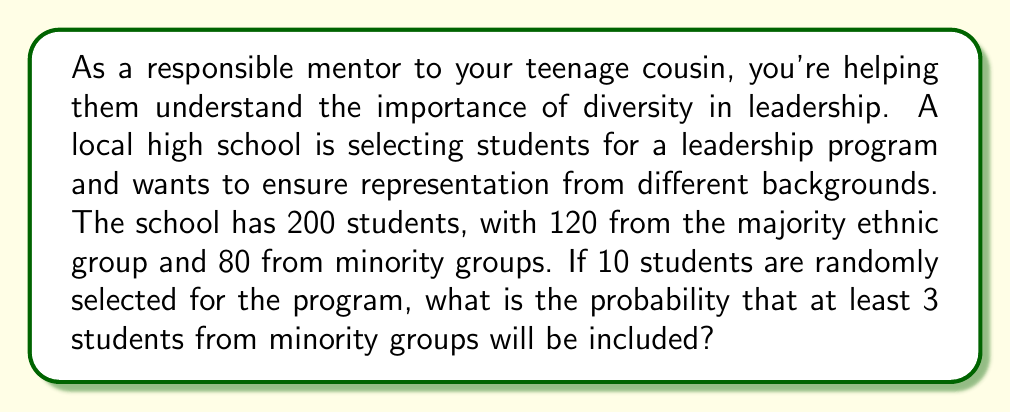What is the answer to this math problem? Let's approach this step-by-step:

1) This is a problem of hypergeometric distribution. We need to find the probability of selecting at least 3 students from minority groups out of 10 selected students.

2) Let's define our variables:
   $N$ = total number of students = 200
   $K$ = number of students from minority groups = 80
   $n$ = number of students selected for the program = 10
   $k$ = number of minority students we want in the selection (at least 3)

3) The probability of selecting exactly $x$ minority students is:

   $$P(X=x) = \frac{\binom{K}{x} \binom{N-K}{n-x}}{\binom{N}{n}}$$

4) We want the probability of selecting at least 3 minority students. This is equivalent to 1 minus the probability of selecting 0, 1, or 2 minority students:

   $$P(X \geq 3) = 1 - [P(X=0) + P(X=1) + P(X=2)]$$

5) Let's calculate each probability:

   $$P(X=0) = \frac{\binom{80}{0} \binom{120}{10}}{\binom{200}{10}} = \frac{1 \cdot 6,906,900}{22,451,004,309} \approx 0.0003076$$

   $$P(X=1) = \frac{\binom{80}{1} \binom{120}{9}}{\binom{200}{10}} = \frac{80 \cdot 1,677,106}{22,451,004,309} \approx 0.0059789$$

   $$P(X=2) = \frac{\binom{80}{2} \binom{120}{8}}{\binom{200}{10}} = \frac{3,160 \cdot 375,060}{22,451,004,309} \approx 0.0528173$$

6) Now, we can calculate the probability of at least 3 minority students:

   $$P(X \geq 3) = 1 - [0.0003076 + 0.0059789 + 0.0528173] = 1 - 0.0591038 = 0.9408962$$
Answer: The probability of selecting at least 3 students from minority groups is approximately 0.9409 or 94.09%. 